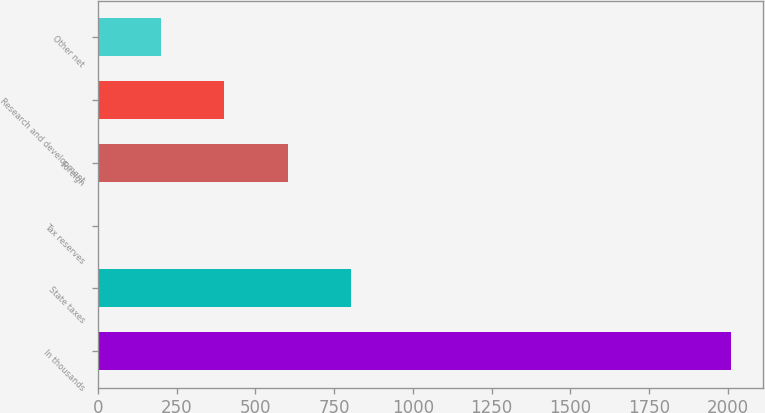<chart> <loc_0><loc_0><loc_500><loc_500><bar_chart><fcel>In thousands<fcel>State taxes<fcel>Tax reserves<fcel>Foreign<fcel>Research and development<fcel>Other net<nl><fcel>2010<fcel>804.12<fcel>0.2<fcel>603.14<fcel>402.16<fcel>201.18<nl></chart> 